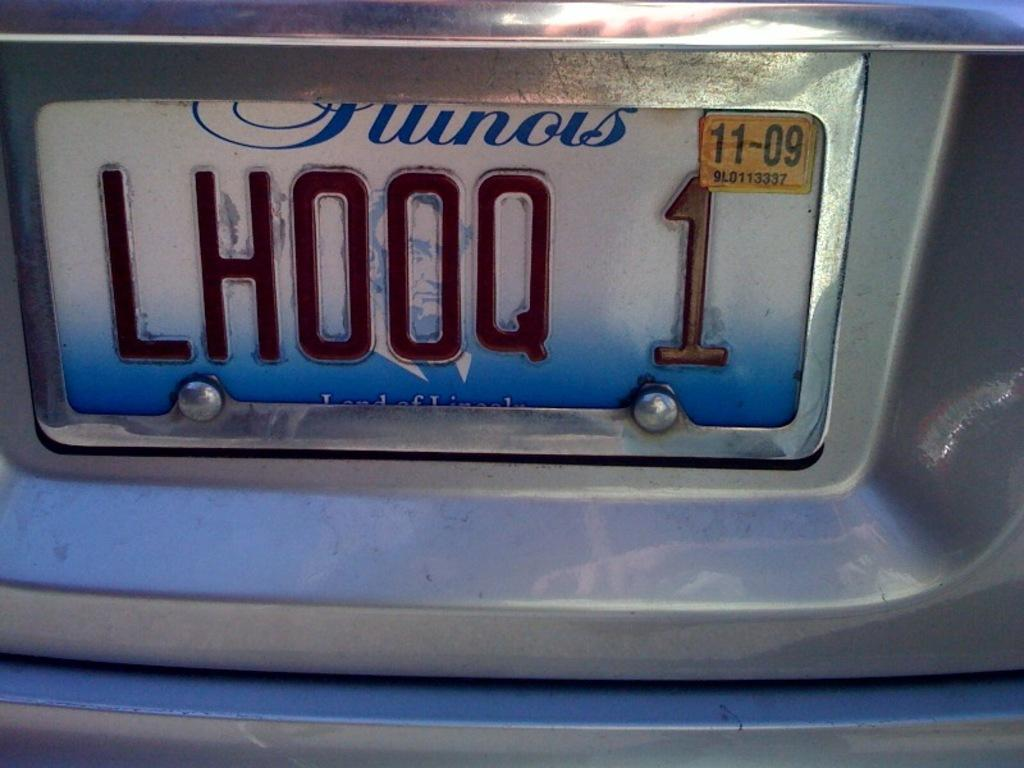<image>
Create a compact narrative representing the image presented. An Illinois license plate has a yellow registration sticker on it. 